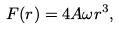Convert formula to latex. <formula><loc_0><loc_0><loc_500><loc_500>F ( r ) = 4 A \omega r ^ { 3 } ,</formula> 